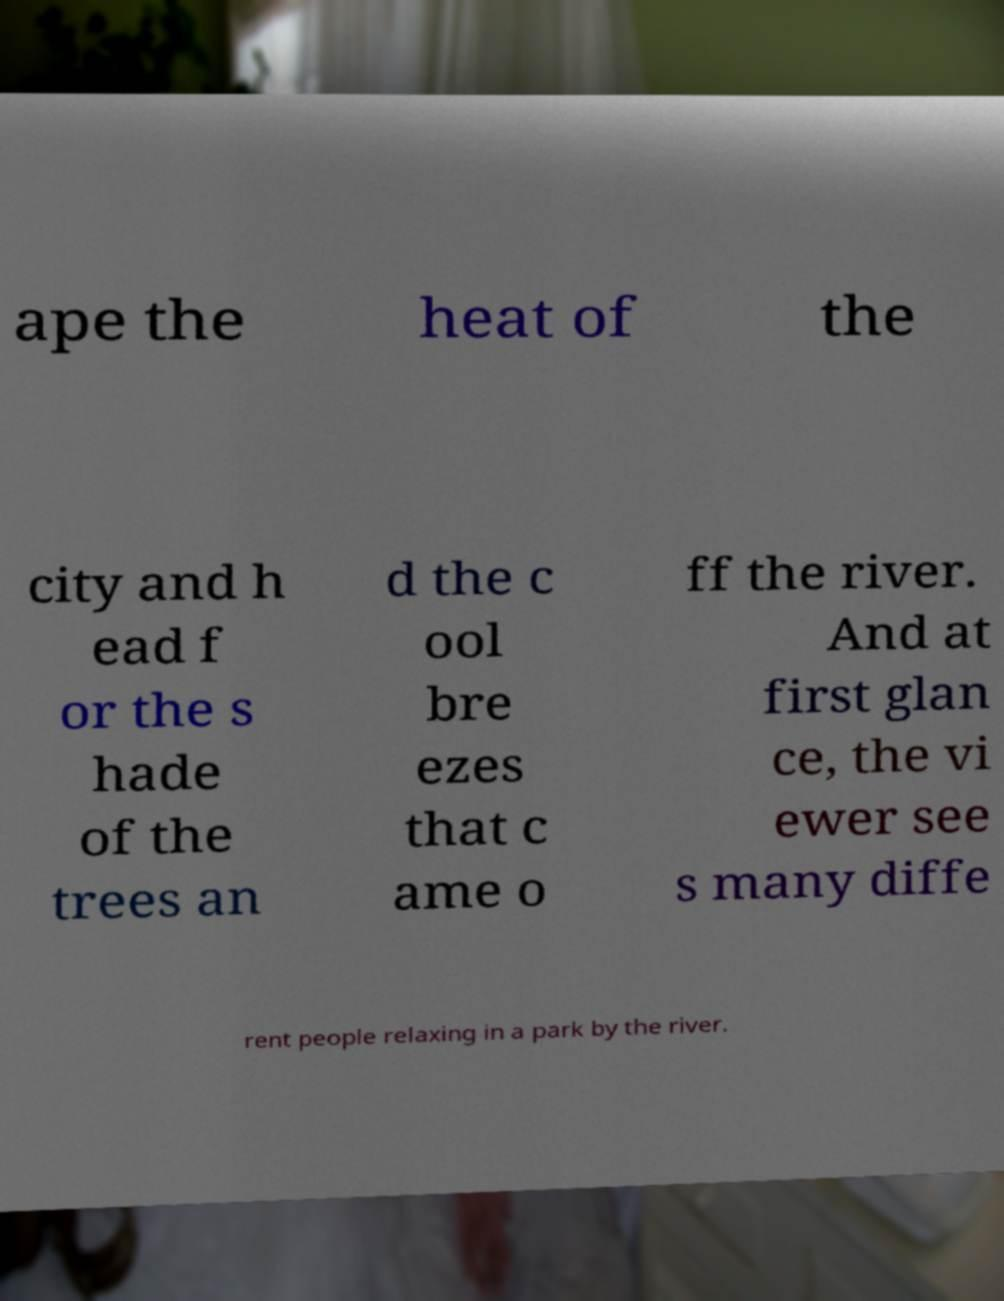For documentation purposes, I need the text within this image transcribed. Could you provide that? ape the heat of the city and h ead f or the s hade of the trees an d the c ool bre ezes that c ame o ff the river. And at first glan ce, the vi ewer see s many diffe rent people relaxing in a park by the river. 